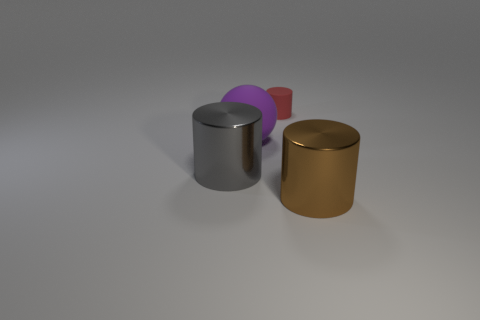Is there any other thing that is the same size as the red rubber cylinder?
Give a very brief answer. No. Is the color of the tiny rubber cylinder the same as the large metallic cylinder that is right of the small rubber cylinder?
Ensure brevity in your answer.  No. What number of cubes are either rubber objects or small red metallic things?
Provide a short and direct response. 0. What color is the big metallic object that is right of the large gray metallic cylinder?
Offer a very short reply. Brown. How many red cylinders are the same size as the brown metal thing?
Your answer should be very brief. 0. Is the shape of the brown metallic object that is right of the small red object the same as the metallic object to the left of the big brown cylinder?
Offer a terse response. Yes. The big object that is behind the shiny cylinder on the left side of the thing in front of the gray object is made of what material?
Provide a short and direct response. Rubber. There is a brown shiny thing that is the same size as the purple sphere; what is its shape?
Your answer should be compact. Cylinder. Are there any other small cylinders that have the same color as the matte cylinder?
Offer a very short reply. No. How big is the matte sphere?
Your answer should be compact. Large. 